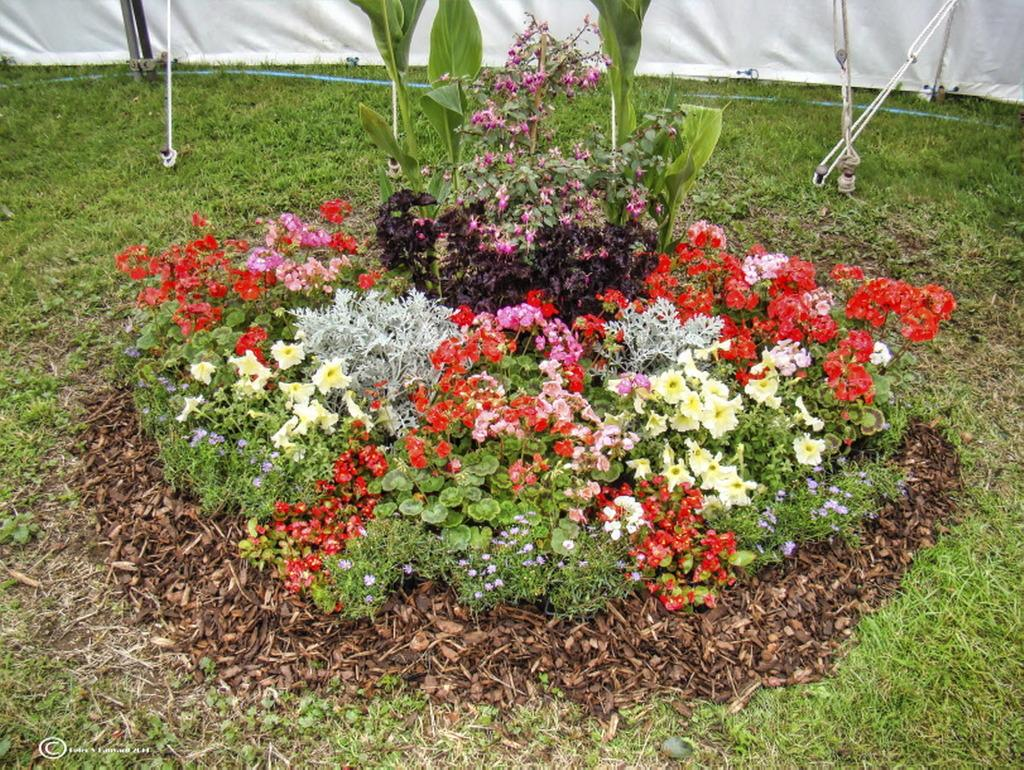What type of plants can be seen in the image? There are plants with colorful flowers in the image. What type of vegetation is present in the image? There is grass in the image. What type of shelter is visible in the image? There is a tent in the image. Is there any indication of the image's origin or ownership? Yes, there is a watermark on the image. What type of nail is being used to hold the tent in the image? There is no nail visible in the image; the tent appears to be secured by other means. Can you see a tank in the image? No, there is no tank present in the image. Is there an oven visible in the image? No, there is no oven present in the image. 